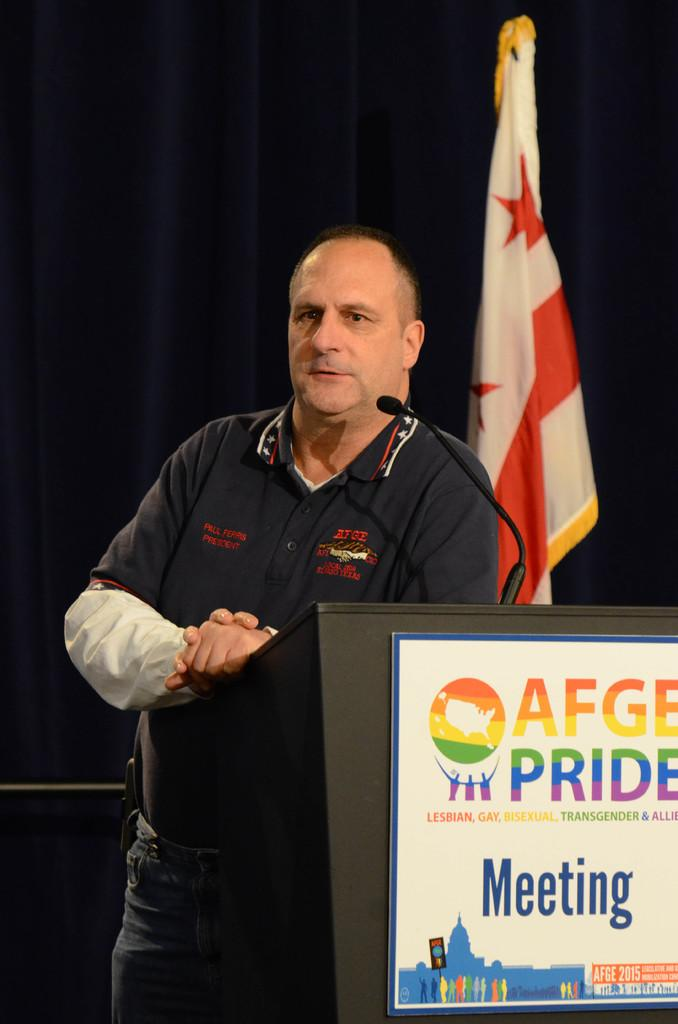What is the person in the image doing near the podium? The person is standing near a podium in the image. What object is present for the person to use for speaking? There is a microphone in the image. What can be seen on the wall behind the person? There is a board and a flag in the background of the image. What type of fabric is present in the background of the image? There is a curtain in the background of the image. How many knots are tied in the account mentioned in the image? There is no mention of an account or knots in the image; it features a person standing near a podium with a microphone, a board, a flag, and a curtain in the background. 